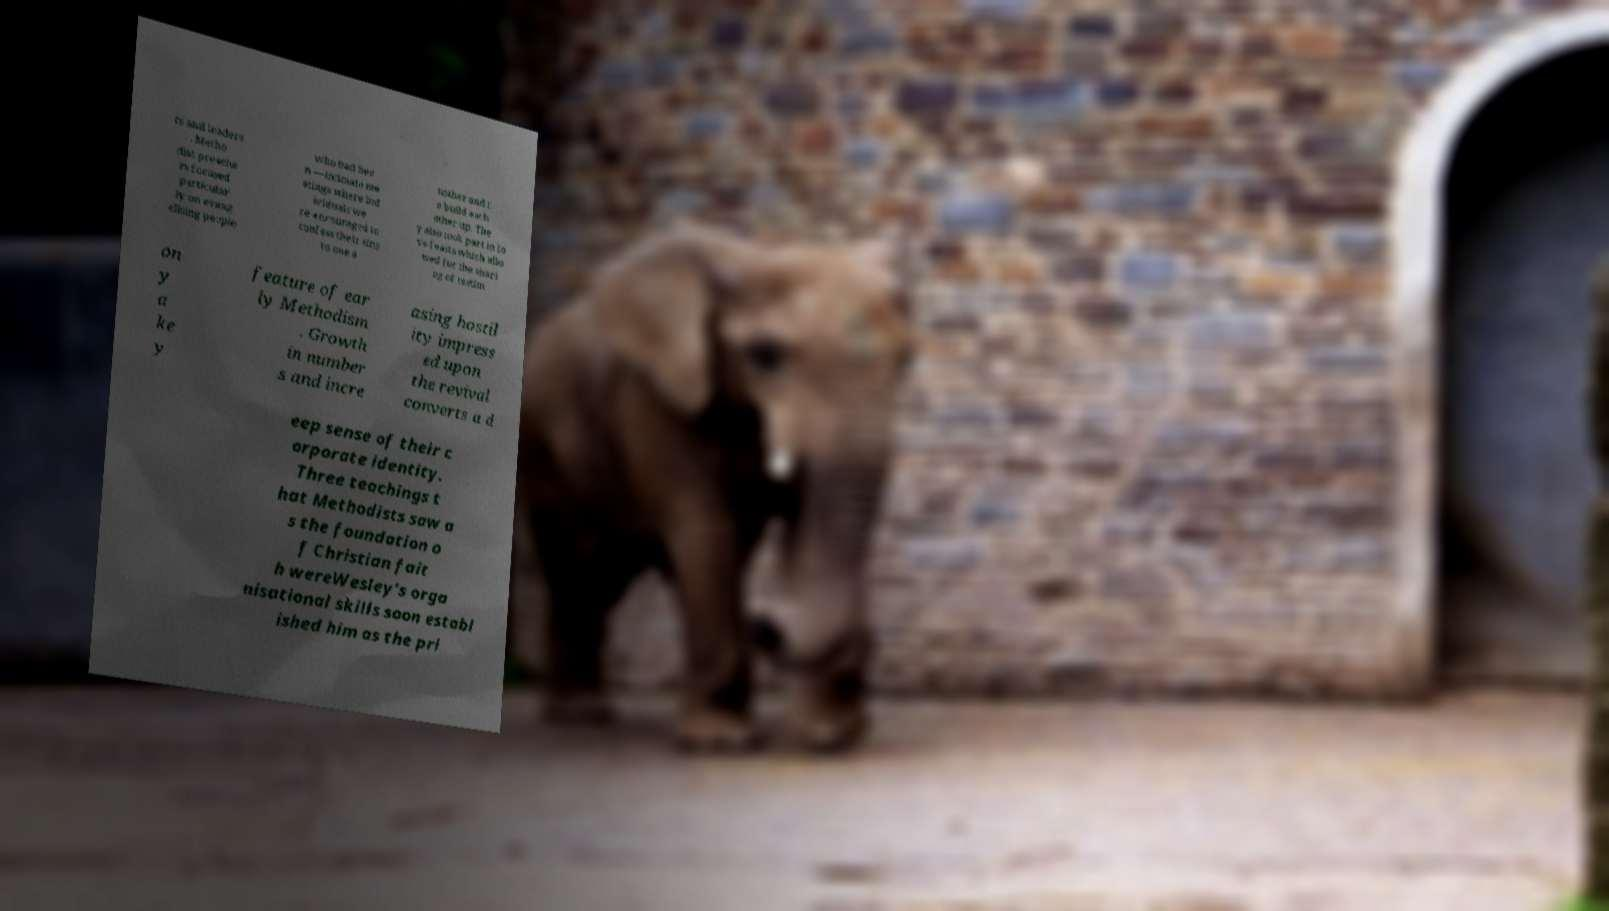Could you extract and type out the text from this image? rs and leaders . Metho dist preache rs focused particular ly on evang elising people who had bee n —intimate me etings where ind ividuals we re encouraged to confess their sins to one a nother and t o build each other up. The y also took part in lo ve feasts which allo wed for the shari ng of testim on y a ke y feature of ear ly Methodism . Growth in number s and incre asing hostil ity impress ed upon the revival converts a d eep sense of their c orporate identity. Three teachings t hat Methodists saw a s the foundation o f Christian fait h wereWesley's orga nisational skills soon establ ished him as the pri 